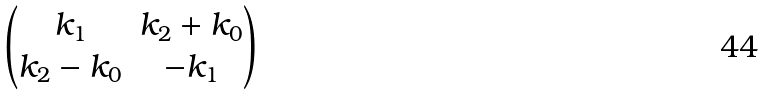<formula> <loc_0><loc_0><loc_500><loc_500>\begin{pmatrix} k _ { 1 } & k _ { 2 } + k _ { 0 } \\ k _ { 2 } - k _ { 0 } & - k _ { 1 } \end{pmatrix}</formula> 